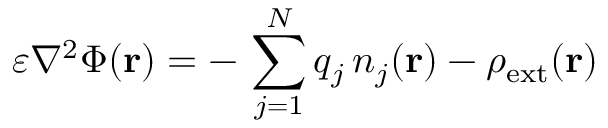<formula> <loc_0><loc_0><loc_500><loc_500>\varepsilon \nabla ^ { 2 } \Phi ( r ) = - \, \sum _ { j = 1 } ^ { N } q _ { j } \, n _ { j } ( r ) - \rho _ { e x t } ( r )</formula> 